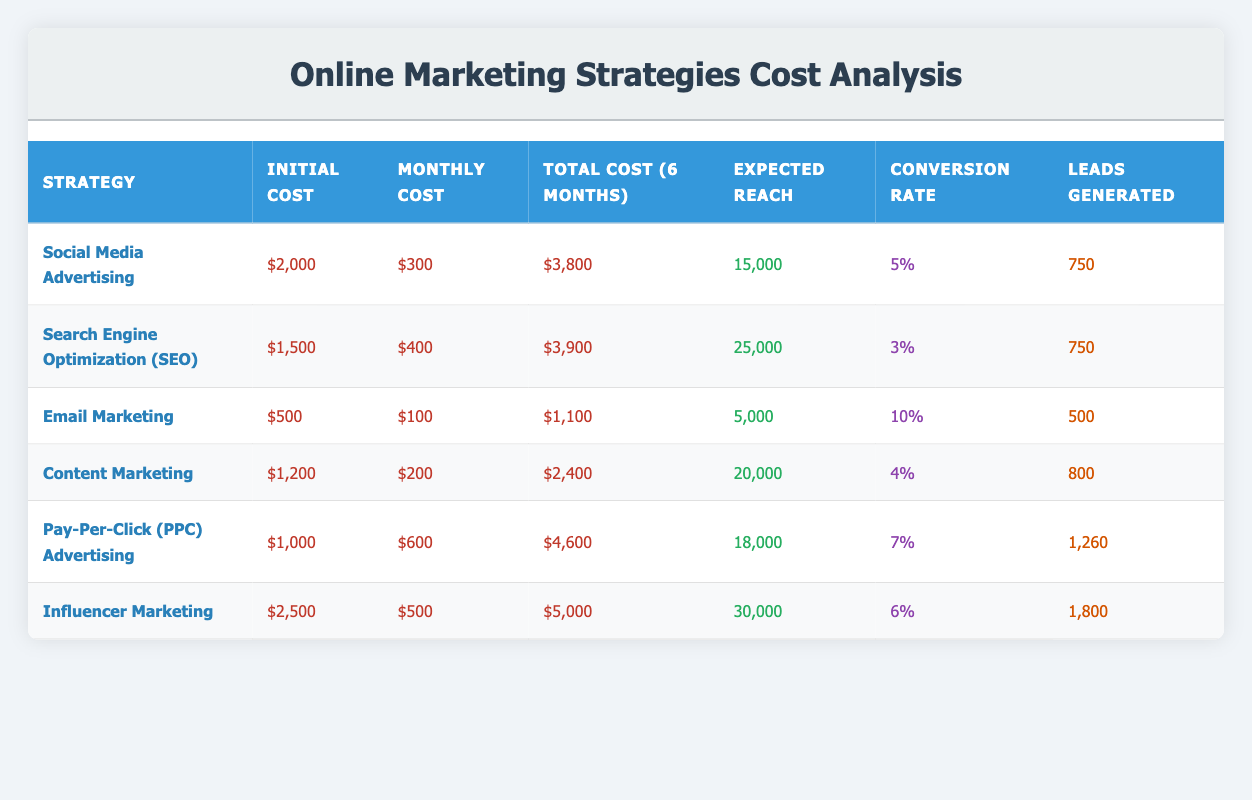What is the total cost of Social Media Advertising over six months? The total cost for Social Media Advertising is listed directly in the table under "Total Cost (6 months)", which shows $3,800.
Answer: $3,800 What is the conversion rate for Email Marketing? The conversion rate is provided in the table under "Conversion Rate" for Email Marketing, which is 10%.
Answer: 10% Which online marketing strategy generated the highest number of leads? By comparing the "Leads Generated" column, Influencer Marketing generated the most leads with 1,800.
Answer: Influencer Marketing What is the difference in total cost between Pay-Per-Click (PPC) Advertising and Content Marketing? The total cost of PPC Advertising is $4,600 and Content Marketing is $2,400. The difference is $4,600 - $2,400 = $2,200.
Answer: $2,200 Is the expected reach higher for SEO than for Email Marketing? The expected reach for SEO is 25,000, while for Email Marketing it is 5,000. Thus, 25,000 is greater than 5,000.
Answer: Yes What is the average monthly cost of the listed online marketing strategies? The monthly costs are: $300, $400, $100, $200, $600, and $500. The total is $300 + $400 + $100 + $200 + $600 + $500 = $2,100. The average is $2,100 / 6 = $350.
Answer: $350 Which strategy has the lowest initial cost, and what is that cost? By looking at the "Initial Cost" column, Email Marketing has the lowest initial cost of $500.
Answer: Email Marketing, $500 How many leads were generated in total across all marketing strategies? Summing the leads generated: 750 + 750 + 500 + 800 + 1260 + 1800 = 5,060 leads were generated in total.
Answer: 5,060 Does Pay-Per-Click (PPC) Advertising have a higher expected reach than Content Marketing? The expected reach for PPC Advertising is 18,000 and for Content Marketing is 20,000. Since 18,000 is less than 20,000, the answer is no.
Answer: No 